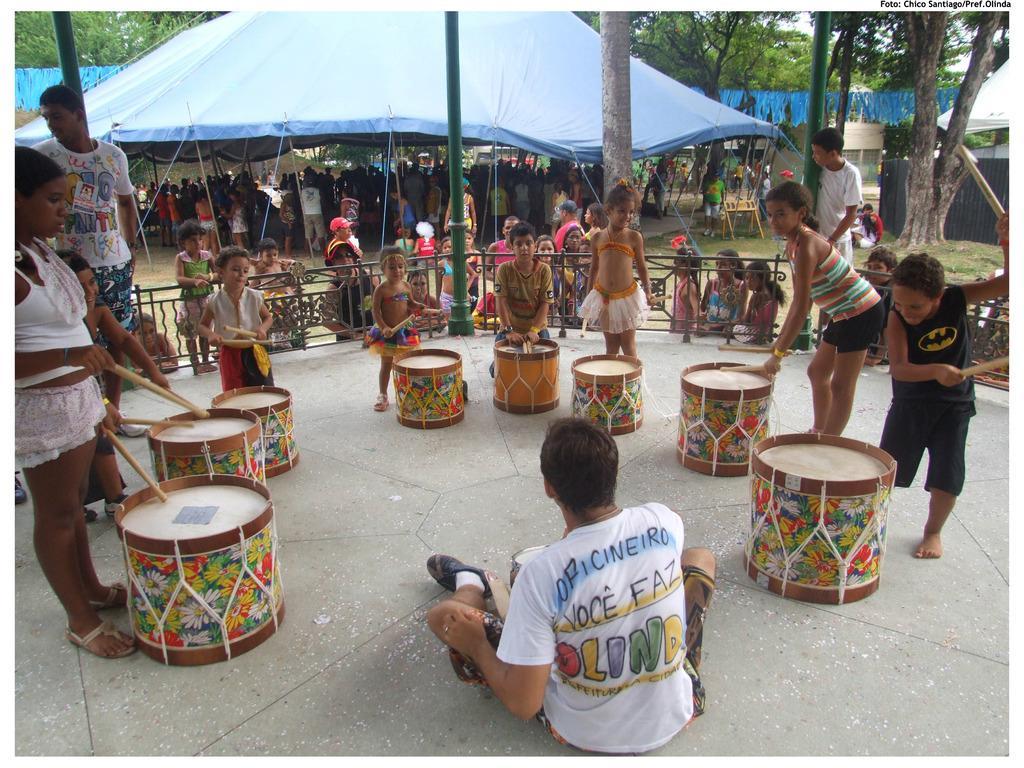How would you summarize this image in a sentence or two? all the persons standing and playing drums. Wec On the background we can see and a tent in blue color. under the tent there are persons standing. This is a grass. Here we can see 